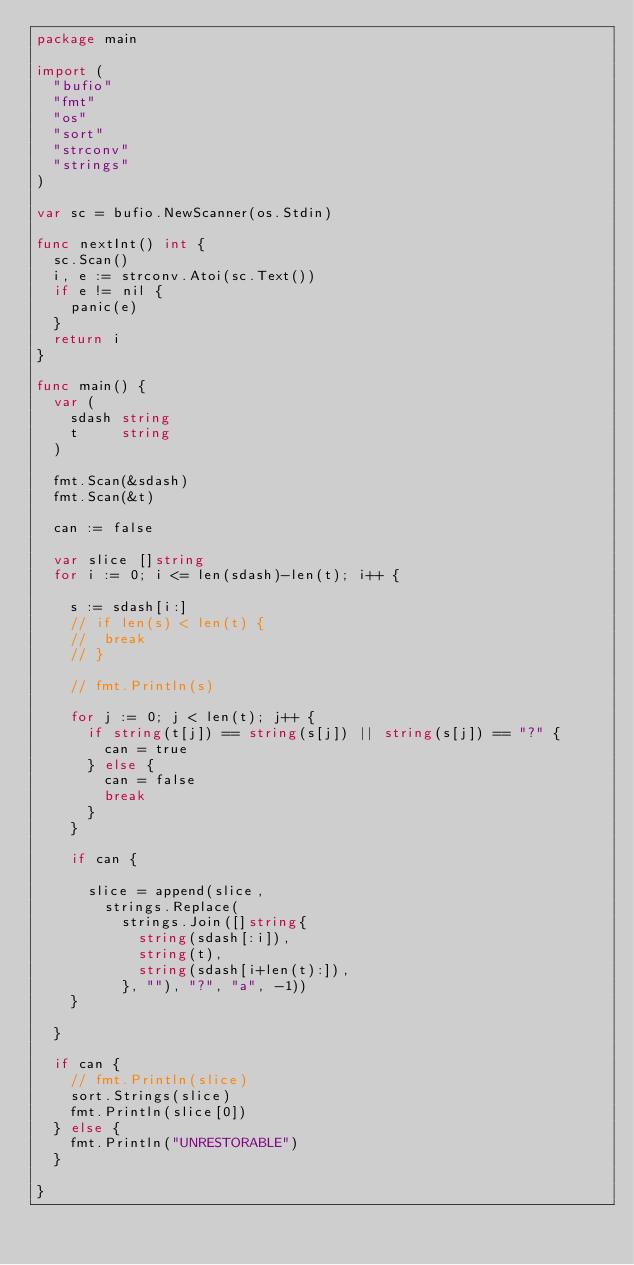Convert code to text. <code><loc_0><loc_0><loc_500><loc_500><_Go_>package main

import (
	"bufio"
	"fmt"
	"os"
	"sort"
	"strconv"
	"strings"
)

var sc = bufio.NewScanner(os.Stdin)

func nextInt() int {
	sc.Scan()
	i, e := strconv.Atoi(sc.Text())
	if e != nil {
		panic(e)
	}
	return i
}

func main() {
	var (
		sdash string
		t     string
	)

	fmt.Scan(&sdash)
	fmt.Scan(&t)

	can := false

	var slice []string
	for i := 0; i <= len(sdash)-len(t); i++ {

		s := sdash[i:]
		// if len(s) < len(t) {
		// 	break
		// }

		// fmt.Println(s)

		for j := 0; j < len(t); j++ {
			if string(t[j]) == string(s[j]) || string(s[j]) == "?" {
				can = true
			} else {
				can = false
				break
			}
		}

		if can {

			slice = append(slice,
				strings.Replace(
					strings.Join([]string{
						string(sdash[:i]),
						string(t),
						string(sdash[i+len(t):]),
					}, ""), "?", "a", -1))
		}

	}

	if can {
		// fmt.Println(slice)
		sort.Strings(slice)
		fmt.Println(slice[0])
	} else {
		fmt.Println("UNRESTORABLE")
	}

}
</code> 